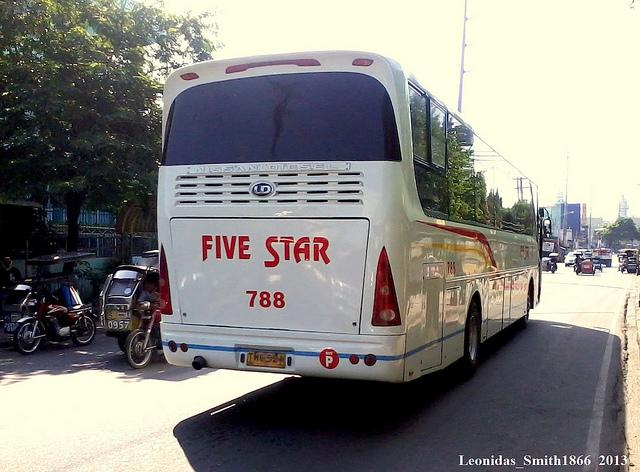What letter is on the bumper?

Choices:
A) p
B) 
C) g
D) o p 